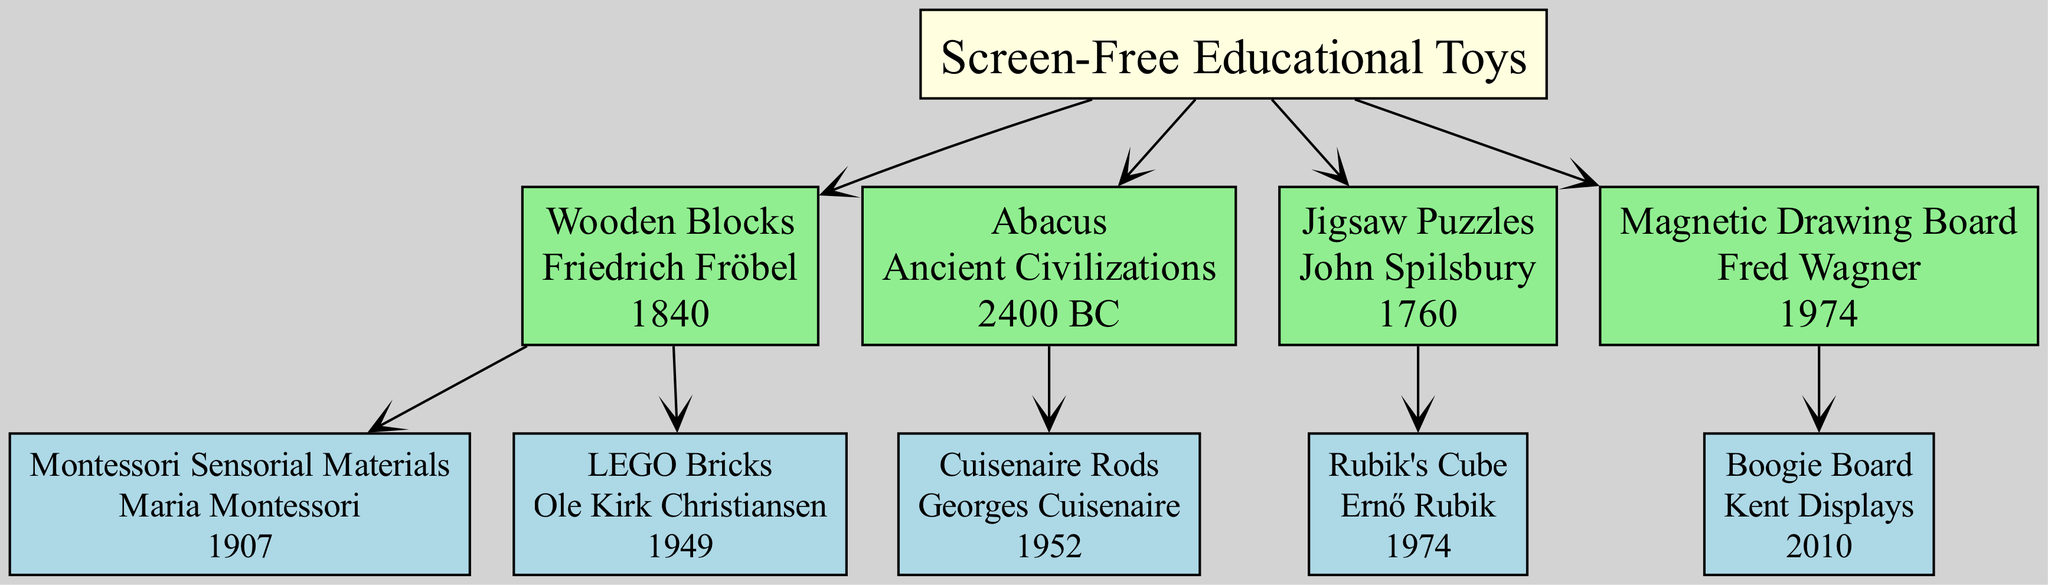What is the earliest invention listed in the family tree? The family tree indicates the timeline of inventions, starting from the creation of the Abacus in 2400 BC, which is the earliest entry among the listed toys.
Answer: Abacus Who invented LEGO Bricks? LEGO Bricks are attributed to Ole Kirk Christiansen, as noted in the diagram under the branch related to Wooden Blocks, which shows its inventor clearly.
Answer: Ole Kirk Christiansen How many children does the Jigsaw Puzzles section have? The Jigsaw Puzzles section, which is a branch of the family tree, contains one child, specifically the Rubik's Cube, as indicated in the family tree diagram.
Answer: 1 What year were Cuisenaire Rods invented? According to the diagram, Cuisenaire Rods were invented in the year 1952, which is shown clearly beneath their name in the family tree.
Answer: 1952 What is the relationship between Wooden Blocks and Montessori Sensorial Materials? The relationship is that Montessori Sensorial Materials are considered a child of the Wooden Blocks branch, as indicated by their connection in the family tree structure.
Answer: Child What color represents the root of the family tree? The diagram shows that the root, labeled Screen-Free Educational Toys, is highlighted in light yellow, making it distinct among other colored branches.
Answer: Light yellow Which inventor is linked with the Magnetic Drawing Board? The inventor Fred Wagner is clearly associated with the Magnetic Drawing Board in the diagram, indicated by the line connecting the two.
Answer: Fred Wagner Which invention was created in the same year as the Magnetic Drawing Board? Both the Magnetic Drawing Board and the Rubik's Cube were invented in the year 1974, showing an overlap in the timeline of these two inventions.
Answer: 1974 How many branches stem from the "Screen-Free Educational Toys"? The family tree displays four branches stemming from the "Screen-Free Educational Toys," which can be counted directly from the diagram.
Answer: 4 